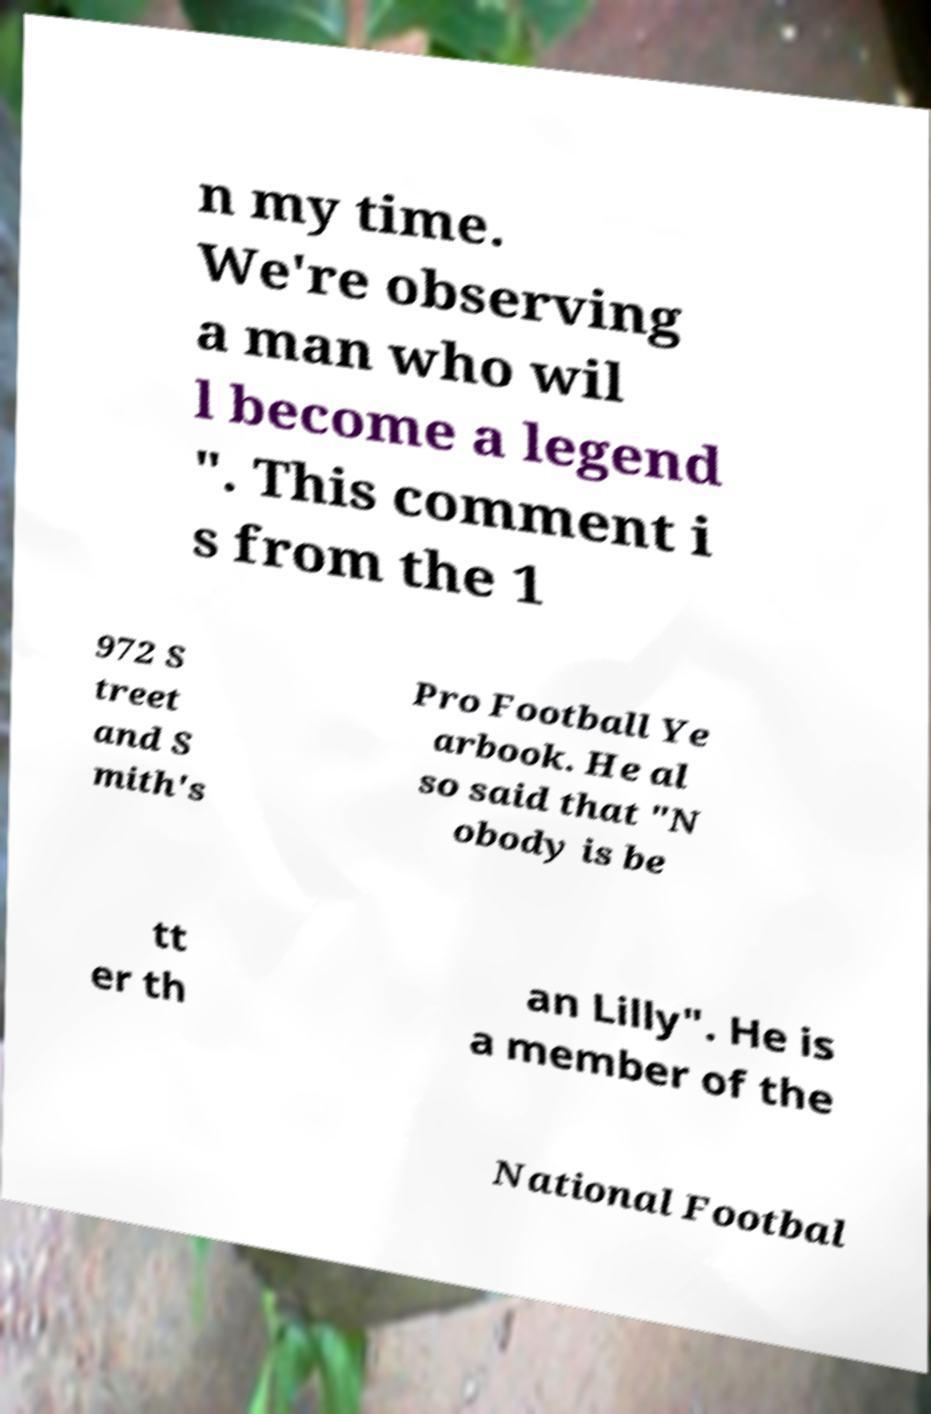Could you assist in decoding the text presented in this image and type it out clearly? n my time. We're observing a man who wil l become a legend ". This comment i s from the 1 972 S treet and S mith's Pro Football Ye arbook. He al so said that "N obody is be tt er th an Lilly". He is a member of the National Footbal 